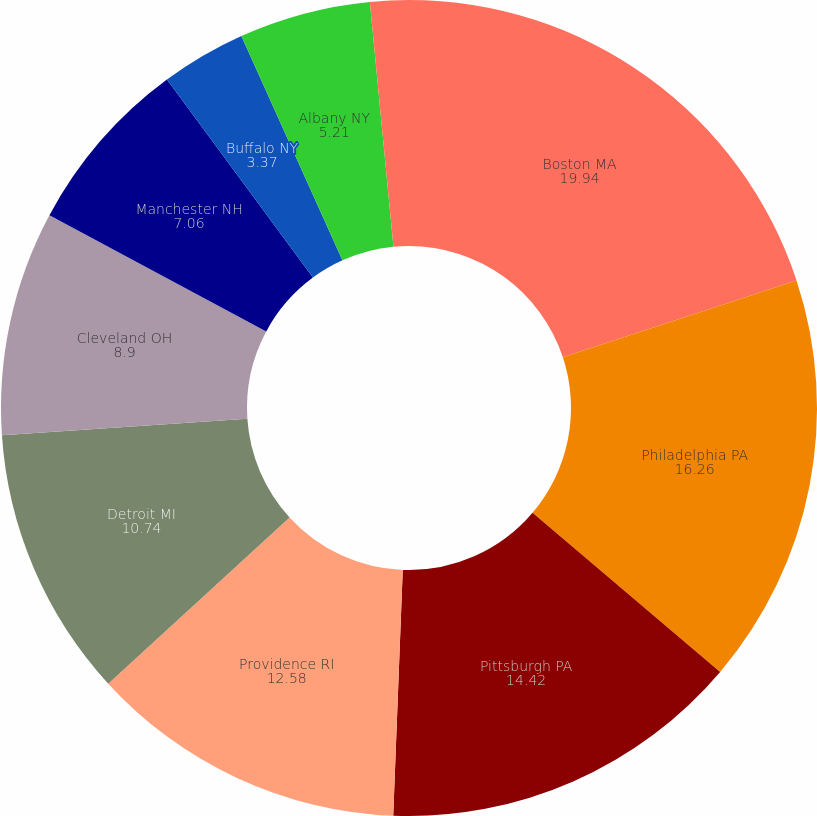Convert chart to OTSL. <chart><loc_0><loc_0><loc_500><loc_500><pie_chart><fcel>Boston MA<fcel>Philadelphia PA<fcel>Pittsburgh PA<fcel>Providence RI<fcel>Detroit MI<fcel>Cleveland OH<fcel>Manchester NH<fcel>Buffalo NY<fcel>Albany NY<fcel>Rochester NY<nl><fcel>19.94%<fcel>16.26%<fcel>14.42%<fcel>12.58%<fcel>10.74%<fcel>8.9%<fcel>7.06%<fcel>3.37%<fcel>5.21%<fcel>1.53%<nl></chart> 